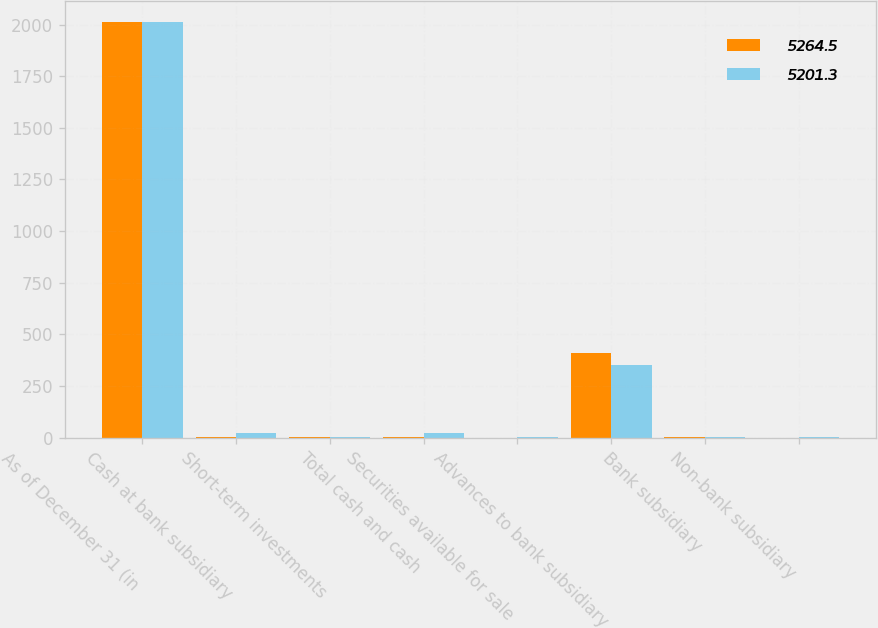Convert chart to OTSL. <chart><loc_0><loc_0><loc_500><loc_500><stacked_bar_chart><ecel><fcel>As of December 31 (in<fcel>Cash at bank subsidiary<fcel>Short-term investments<fcel>Total cash and cash<fcel>Securities available for sale<fcel>Advances to bank subsidiary<fcel>Bank subsidiary<fcel>Non-bank subsidiary<nl><fcel>5264.5<fcel>2014<fcel>3.1<fcel>1.2<fcel>4.3<fcel>0.2<fcel>410<fcel>3.7<fcel>0.4<nl><fcel>5201.3<fcel>2013<fcel>20.2<fcel>1.7<fcel>21.9<fcel>2.7<fcel>353<fcel>3.7<fcel>1.5<nl></chart> 